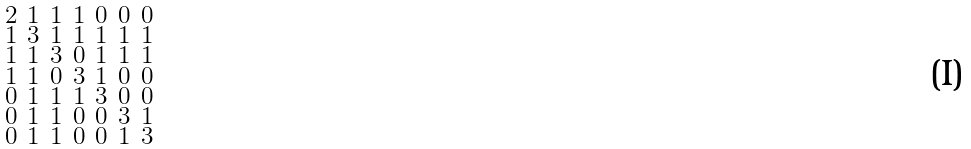<formula> <loc_0><loc_0><loc_500><loc_500>\begin{smallmatrix} 2 & 1 & 1 & 1 & 0 & 0 & 0 \\ 1 & 3 & 1 & 1 & 1 & 1 & 1 \\ 1 & 1 & 3 & 0 & 1 & 1 & 1 \\ 1 & 1 & 0 & 3 & 1 & 0 & 0 \\ 0 & 1 & 1 & 1 & 3 & 0 & 0 \\ 0 & 1 & 1 & 0 & 0 & 3 & 1 \\ 0 & 1 & 1 & 0 & 0 & 1 & 3 \end{smallmatrix}</formula> 